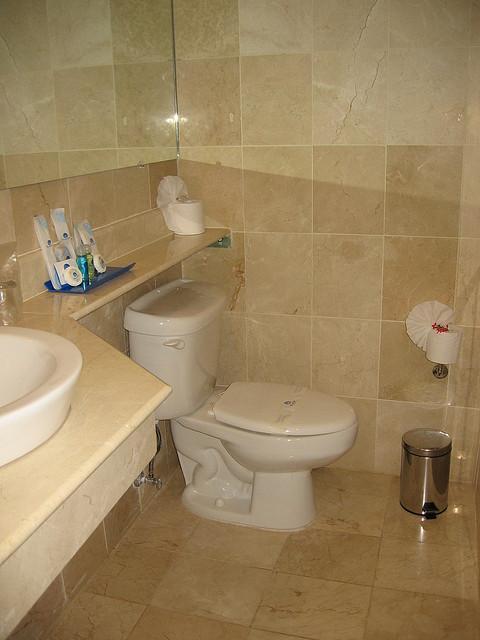How many rolls of toilet paper are there?
Give a very brief answer. 2. How many toilets are visible?
Give a very brief answer. 1. How many boxes of pizza are on the table?
Give a very brief answer. 0. 